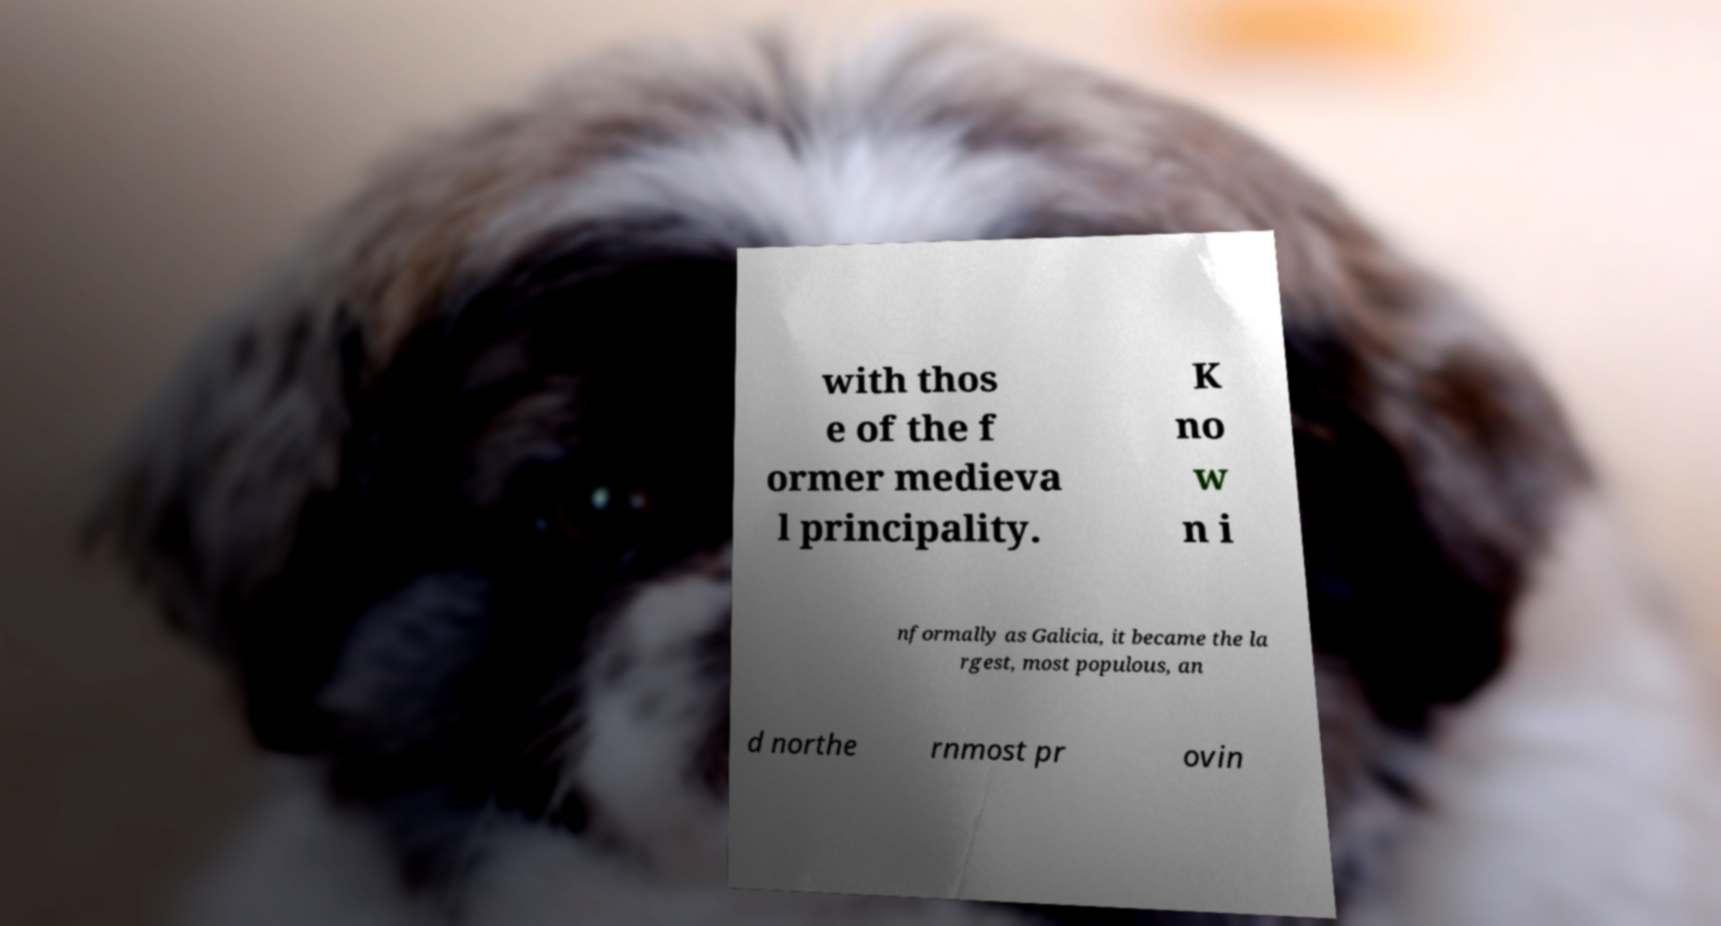Can you read and provide the text displayed in the image?This photo seems to have some interesting text. Can you extract and type it out for me? with thos e of the f ormer medieva l principality. K no w n i nformally as Galicia, it became the la rgest, most populous, an d northe rnmost pr ovin 